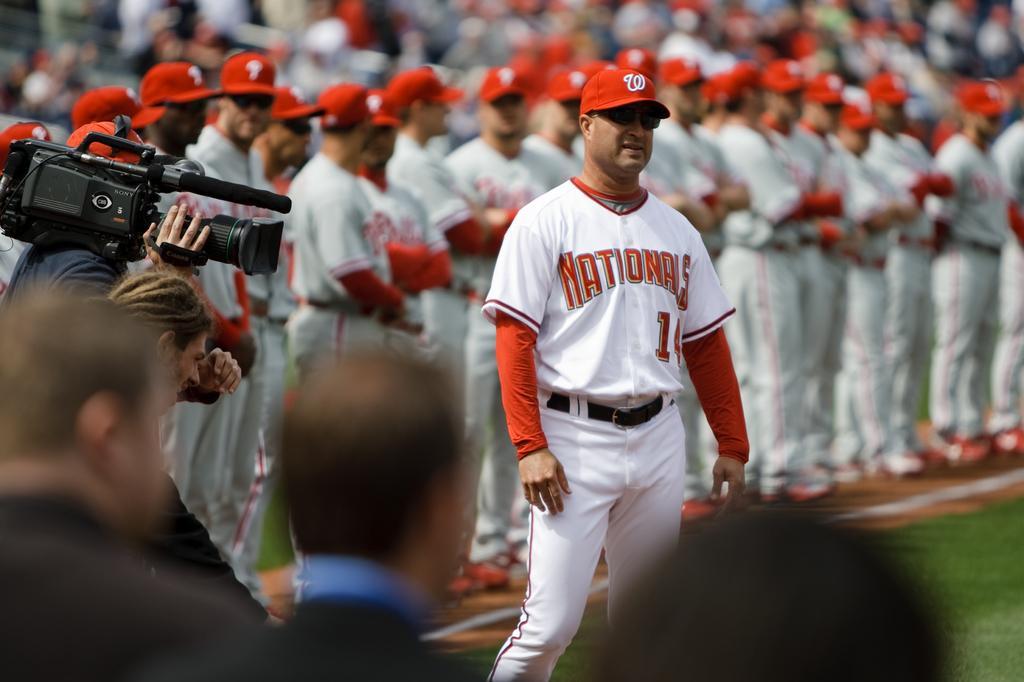In one or two sentences, can you explain what this image depicts? In this image I can see number of people are standing. I can see most of them are wearing white colour of dress and red caps. I can also see something is written on their dresses. On the left side of the image I can see one person is holding a camera and I can also see this image is little bit blurry. 